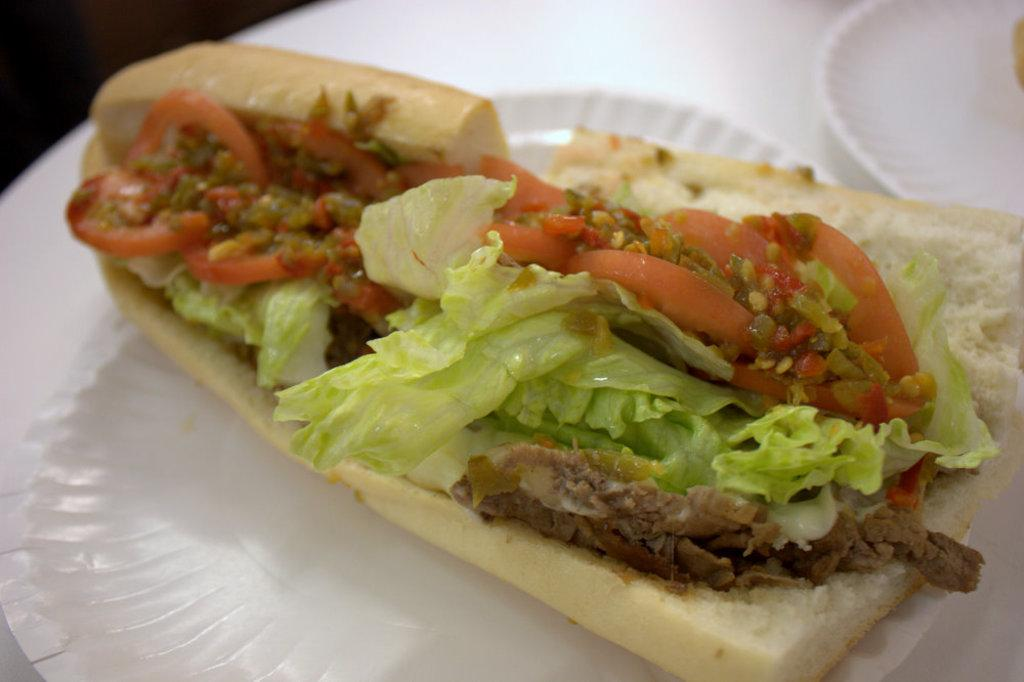What objects are present on the plates in the image? There is food on the plates in the image. What color is the platform that the plates are on? The platform the plates are on is white. How would you describe the background of the image? The background of the image is dark. What time does the clock show in the image? There is no clock present in the image. What surprise does the grandmother have for the children in the image? There is no grandmother or children present in the image, and therefore no surprise can be observed. 